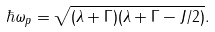<formula> <loc_0><loc_0><loc_500><loc_500>\hbar { \omega } _ { p } = \sqrt { ( \lambda + \Gamma ) ( \lambda + \Gamma - J / 2 ) } .</formula> 